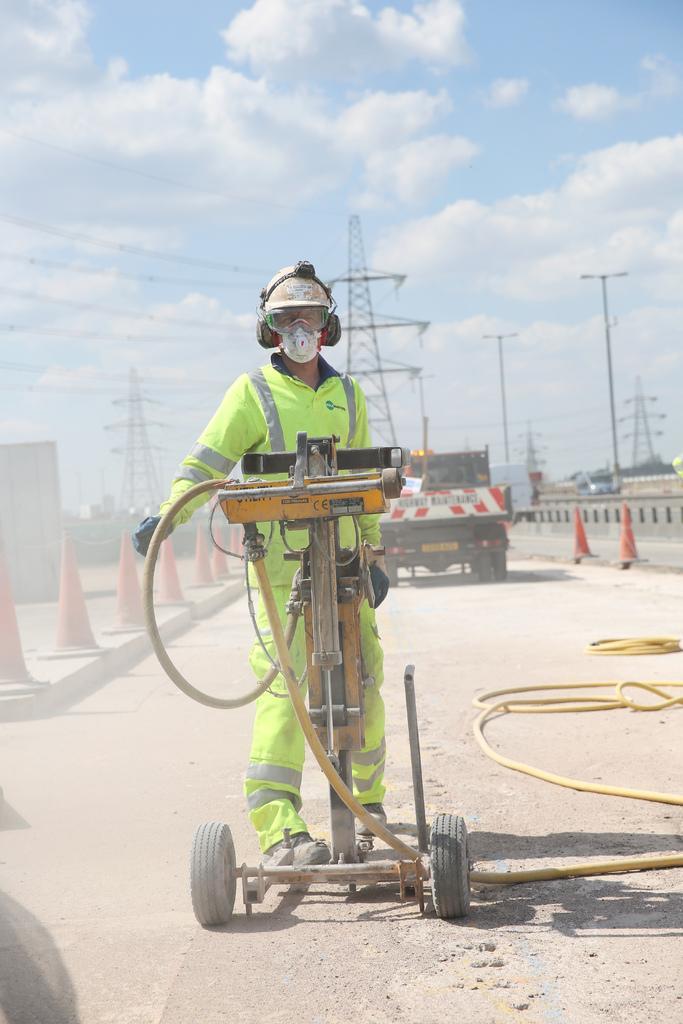In one or two sentences, can you explain what this image depicts? In this image we can see a person person wearing a helmet, in front of him there is a machine, behind him there is a vehicle, there are traffic cones, there is a pipe, light pole, electric towers, wires, also we can see the sky. 